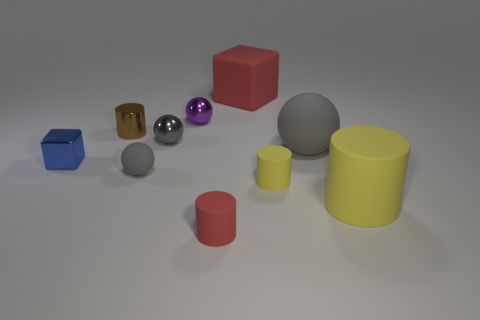Does the large rubber ball have the same color as the tiny rubber ball?
Offer a terse response. Yes. What number of yellow objects are either large matte things or metallic balls?
Make the answer very short. 1. There is a red rubber object that is to the left of the large red object; is its shape the same as the yellow matte object that is right of the big gray rubber ball?
Offer a terse response. Yes. There is a large sphere; does it have the same color as the small shiny ball in front of the tiny brown object?
Your response must be concise. Yes. There is a small shiny ball in front of the brown cylinder; is it the same color as the tiny matte sphere?
Give a very brief answer. Yes. How many objects are big green shiny things or tiny matte things that are to the right of the purple sphere?
Provide a succinct answer. 2. There is a thing that is both in front of the large red cube and behind the tiny brown shiny object; what is its material?
Give a very brief answer. Metal. What is the cube behind the tiny metal cylinder made of?
Make the answer very short. Rubber. The tiny cube that is made of the same material as the brown cylinder is what color?
Offer a very short reply. Blue. There is a small gray shiny thing; is it the same shape as the gray rubber thing that is to the left of the large gray thing?
Ensure brevity in your answer.  Yes. 